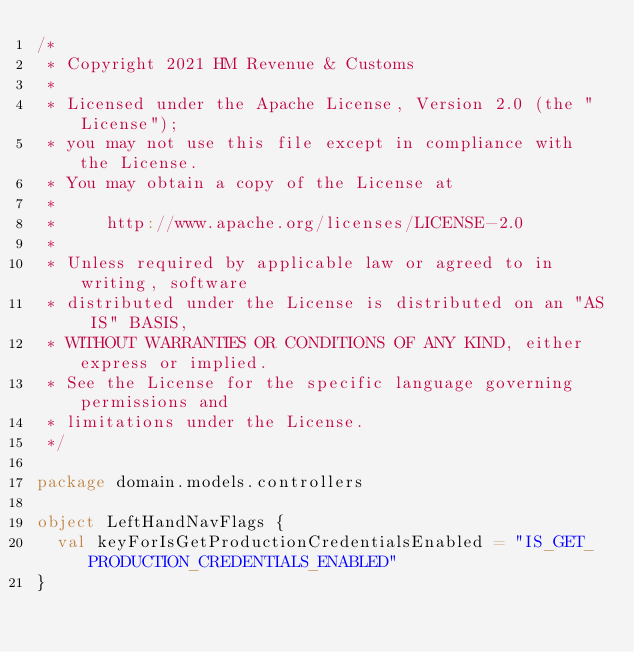<code> <loc_0><loc_0><loc_500><loc_500><_Scala_>/*
 * Copyright 2021 HM Revenue & Customs
 *
 * Licensed under the Apache License, Version 2.0 (the "License");
 * you may not use this file except in compliance with the License.
 * You may obtain a copy of the License at
 *
 *     http://www.apache.org/licenses/LICENSE-2.0
 *
 * Unless required by applicable law or agreed to in writing, software
 * distributed under the License is distributed on an "AS IS" BASIS,
 * WITHOUT WARRANTIES OR CONDITIONS OF ANY KIND, either express or implied.
 * See the License for the specific language governing permissions and
 * limitations under the License.
 */

package domain.models.controllers

object LeftHandNavFlags {
  val keyForIsGetProductionCredentialsEnabled = "IS_GET_PRODUCTION_CREDENTIALS_ENABLED"
}
</code> 